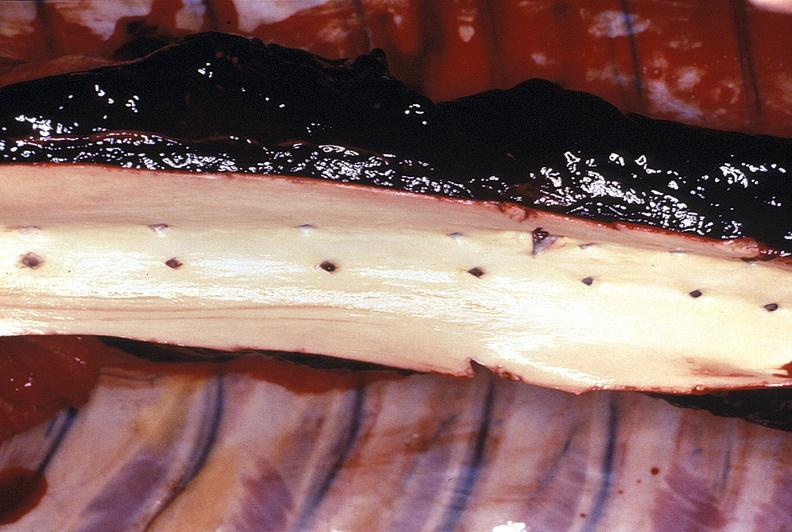where is this?
Answer the question using a single word or phrase. Vasculature 